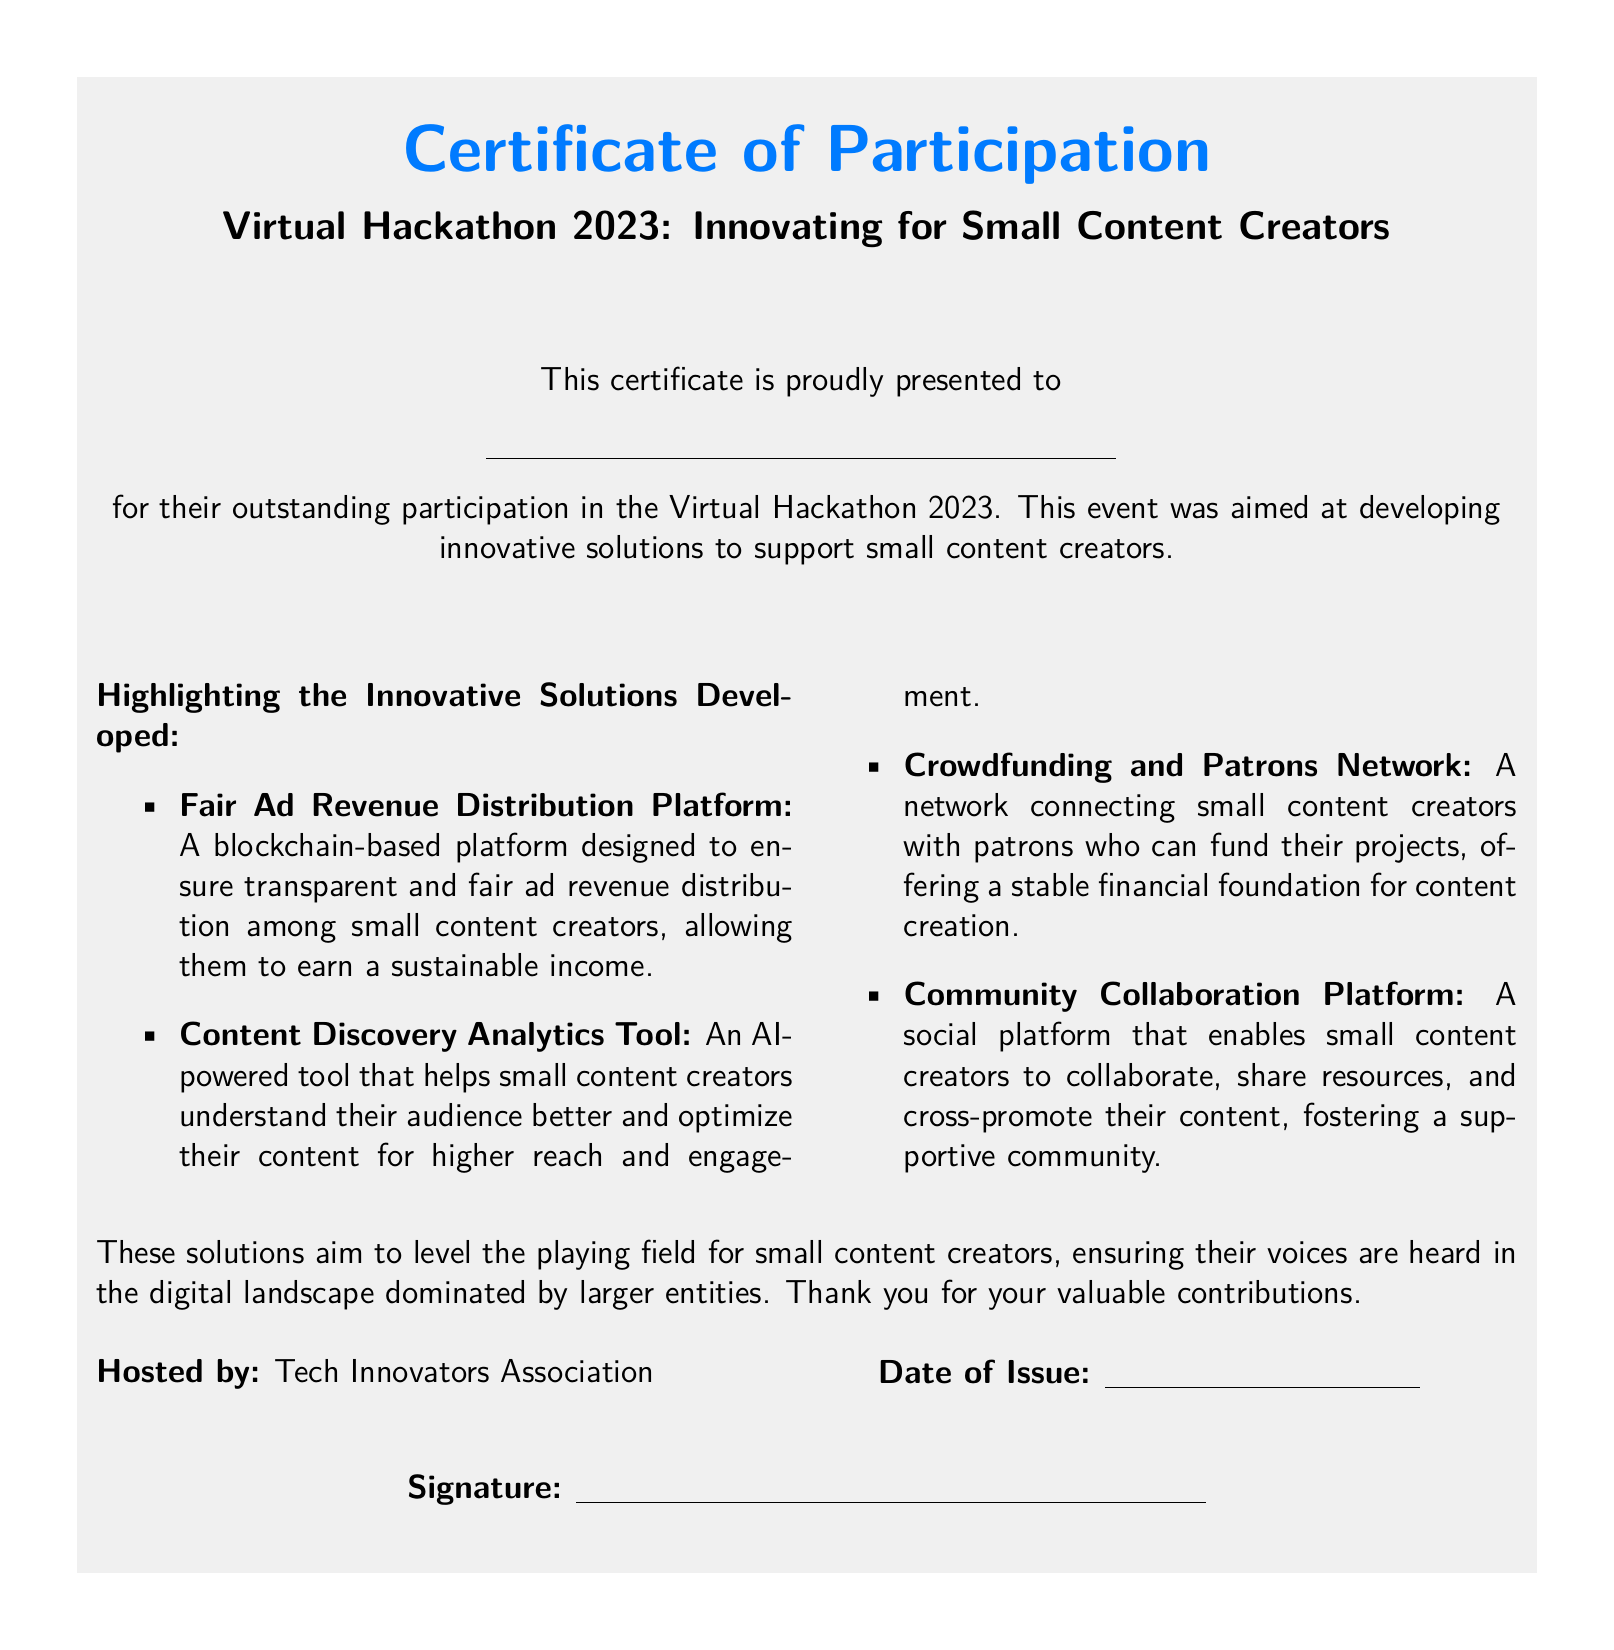What is the title of the event? The title of the event is highlighted in the document, which is "Virtual Hackathon 2023: Innovating for Small Content Creators."
Answer: Virtual Hackathon 2023: Innovating for Small Content Creators Who is the certificate presented to? The recipient's name is indicated as a placeholder line in the document, represented by an underline.
Answer: \underline{\hspace{8cm}} What is the purpose of the hackathon? The document explicitly states that the purpose is to develop innovative solutions to support small content creators.
Answer: Support small content creators What type of platform is the Fair Ad Revenue Distribution Platform based on? The description in the document specifies that the Fair Ad Revenue Distribution Platform is a blockchain-based platform.
Answer: Blockchain-based How many innovative solutions are highlighted in the document? The number of solutions is determined by counting the items listed under "Highlighting the Innovative Solutions Developed."
Answer: Four Who hosted the event? The document provides information about the host, which is stated clearly.
Answer: Tech Innovators Association What is the significance of the solutions mentioned? The document mentions that the solutions aim to level the playing field for small content creators within the digital landscape.
Answer: Level the playing field What is the date of issue placeholder in the document? The document contains a placeholder for the date of issue, represented as an underline.
Answer: \underline{\hspace{4cm}} 